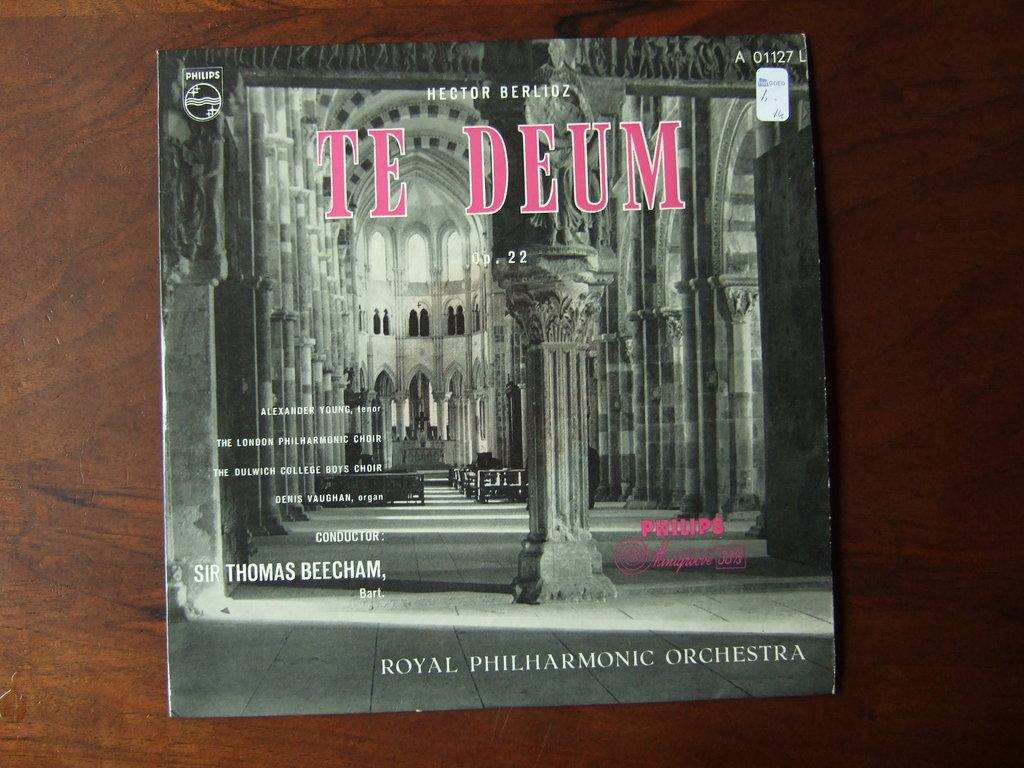<image>
Create a compact narrative representing the image presented. A CD cover titled Te Deum with a cathedral on it. 